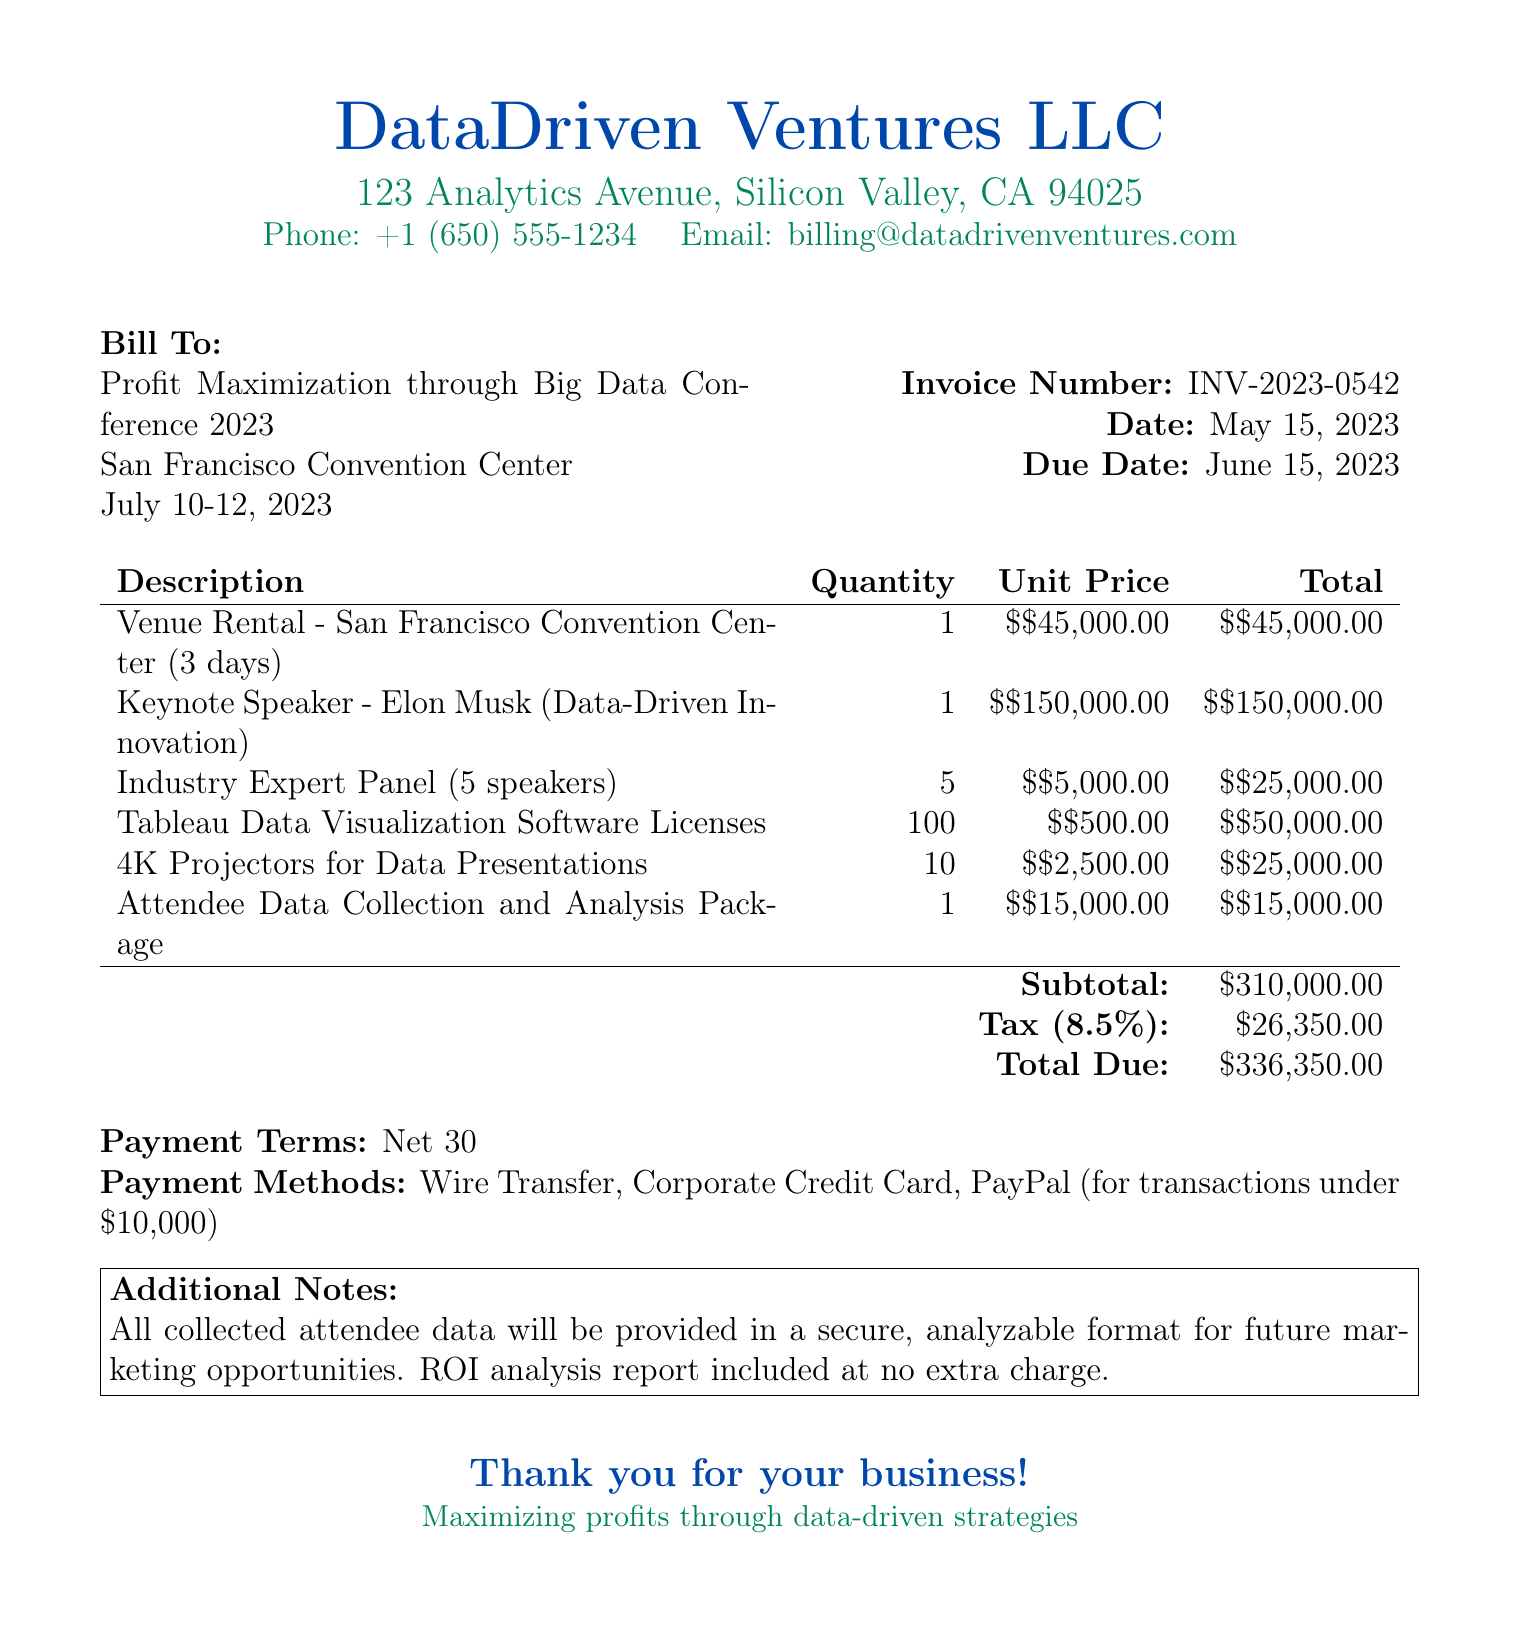What is the invoice number? The invoice number is listed in the document for tracking purposes.
Answer: INV-2023-0542 How much is the venue rental for three days? The cost for the venue rental is specifically mentioned in the invoice section.
Answer: $45,000.00 Who is the keynote speaker? The keynote speaker is an important aspect of the conference program and is mentioned in the document.
Answer: Elon Musk What is the total due amount? The total due amount is a critical figure that summarizes the expenses in the invoice.
Answer: $336,350.00 How many speakers are part of the industry expert panel? The number of speakers for the panel is detailed in the document under the description for that item.
Answer: 5 What percentage is the tax applied to the subtotal? The tax percentage is specified in the breakdown of costs within the invoice.
Answer: 8.5% What payment methods are accepted? Accepted payment methods are clearly outlined in the terms section of the document.
Answer: Wire Transfer, Corporate Credit Card, PayPal When is the payment due? The due date is indicated in the header section of the invoice for payment clarity.
Answer: June 15, 2023 What is included at no extra charge? The additional notes section specifies any included services or reports without extra costs.
Answer: ROI analysis report 